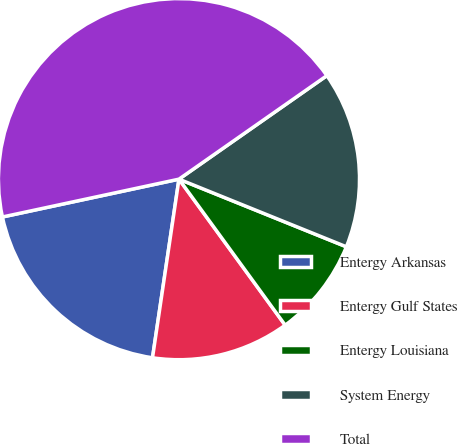Convert chart to OTSL. <chart><loc_0><loc_0><loc_500><loc_500><pie_chart><fcel>Entergy Arkansas<fcel>Entergy Gulf States<fcel>Entergy Louisiana<fcel>System Energy<fcel>Total<nl><fcel>19.3%<fcel>12.35%<fcel>8.88%<fcel>15.83%<fcel>43.64%<nl></chart> 